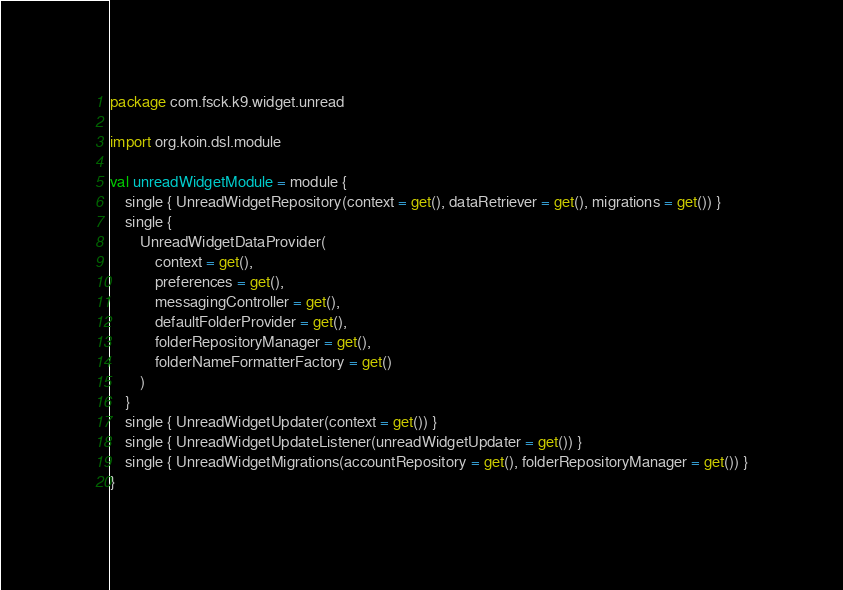<code> <loc_0><loc_0><loc_500><loc_500><_Kotlin_>package com.fsck.k9.widget.unread

import org.koin.dsl.module

val unreadWidgetModule = module {
    single { UnreadWidgetRepository(context = get(), dataRetriever = get(), migrations = get()) }
    single {
        UnreadWidgetDataProvider(
            context = get(),
            preferences = get(),
            messagingController = get(),
            defaultFolderProvider = get(),
            folderRepositoryManager = get(),
            folderNameFormatterFactory = get()
        )
    }
    single { UnreadWidgetUpdater(context = get()) }
    single { UnreadWidgetUpdateListener(unreadWidgetUpdater = get()) }
    single { UnreadWidgetMigrations(accountRepository = get(), folderRepositoryManager = get()) }
}
</code> 